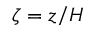<formula> <loc_0><loc_0><loc_500><loc_500>\zeta = z / H</formula> 